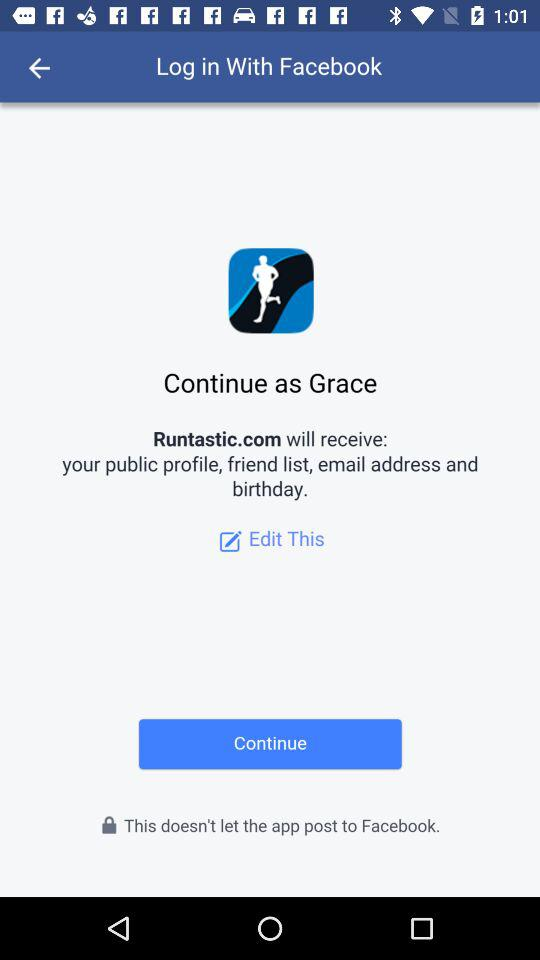What is the user name? The user name is "Grace". 